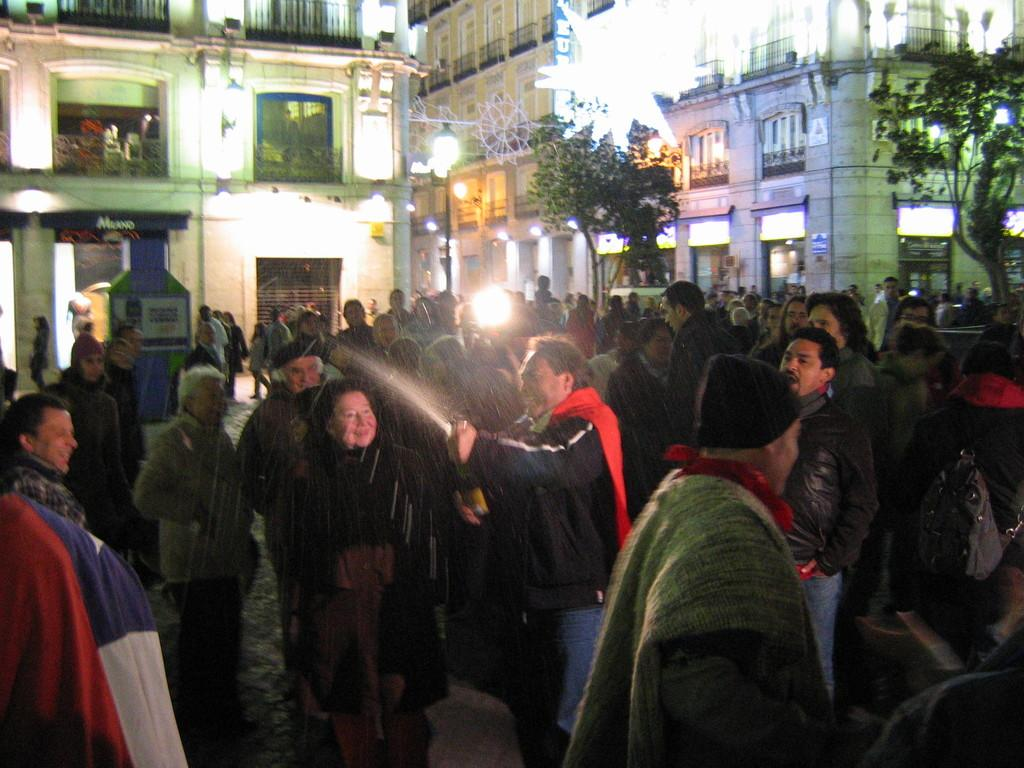How many people are visible in the image? There are many people standing in the image. What can be seen in the background of the image? There are buildings in the background of the image. What are some features of the buildings in the image? The buildings have walls, windows, pillars, and roofs. What type of lighting is present in the image? There are poles with lamps in the image. Can you hear the bells ringing in the image? There are no bells present in the image, so it is not possible to hear them ringing. 